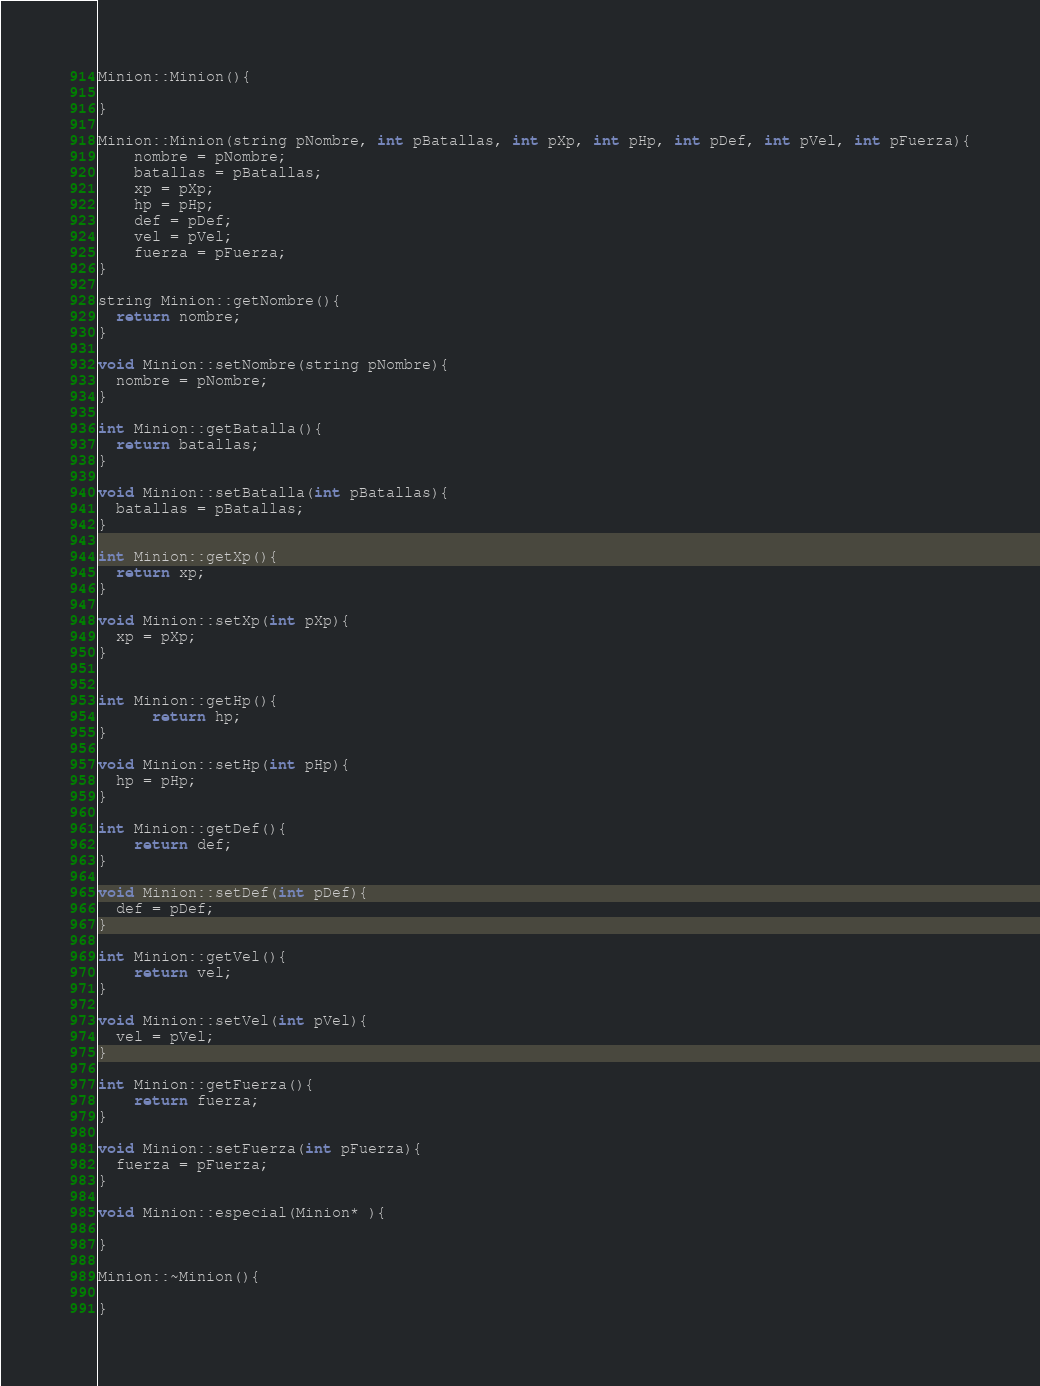<code> <loc_0><loc_0><loc_500><loc_500><_C++_>
Minion::Minion(){

}

Minion::Minion(string pNombre, int pBatallas, int pXp, int pHp, int pDef, int pVel, int pFuerza){
    nombre = pNombre;
    batallas = pBatallas;
    xp = pXp;
    hp = pHp;
    def = pDef;
    vel = pVel;
    fuerza = pFuerza;
}

string Minion::getNombre(){
  return nombre;
}

void Minion::setNombre(string pNombre){
  nombre = pNombre;
}

int Minion::getBatalla(){
  return batallas;
}

void Minion::setBatalla(int pBatallas){
  batallas = pBatallas;
}

int Minion::getXp(){
  return xp;
}

void Minion::setXp(int pXp){
  xp = pXp;
}


int Minion::getHp(){
      return hp;
}

void Minion::setHp(int pHp){
  hp = pHp;
}

int Minion::getDef(){
    return def;
}

void Minion::setDef(int pDef){
  def = pDef;
}

int Minion::getVel(){
    return vel;
}

void Minion::setVel(int pVel){
  vel = pVel;
}

int Minion::getFuerza(){
    return fuerza;
}

void Minion::setFuerza(int pFuerza){
  fuerza = pFuerza;
}

void Minion::especial(Minion* ){

}

Minion::~Minion(){

}
</code> 